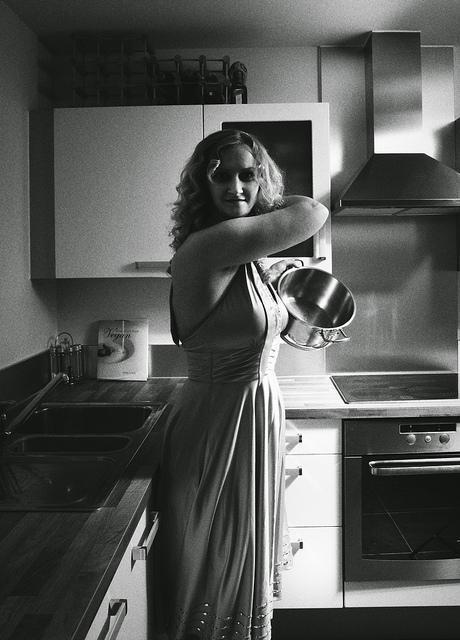How many people are visible?
Give a very brief answer. 1. How many sinks can you see?
Give a very brief answer. 2. 